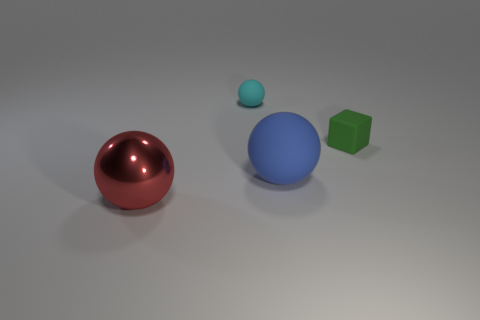Add 3 big cyan shiny objects. How many objects exist? 7 Subtract all brown spheres. Subtract all blue blocks. How many spheres are left? 3 Subtract all cubes. How many objects are left? 3 Subtract 0 brown cylinders. How many objects are left? 4 Subtract all large metallic balls. Subtract all red objects. How many objects are left? 2 Add 2 blue spheres. How many blue spheres are left? 3 Add 3 brown matte things. How many brown matte things exist? 3 